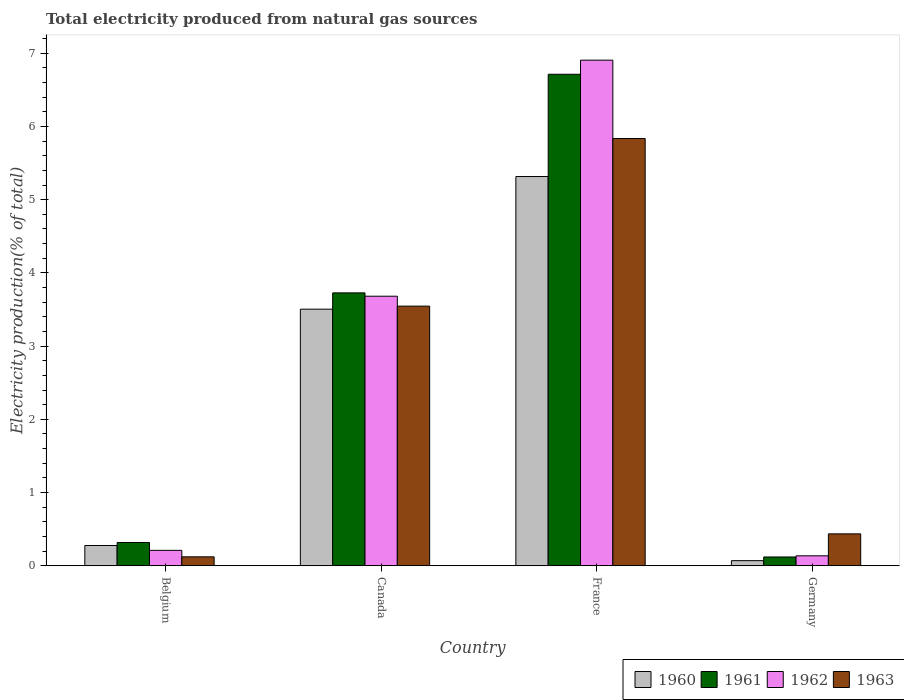How many bars are there on the 1st tick from the left?
Your response must be concise. 4. What is the label of the 3rd group of bars from the left?
Your answer should be very brief. France. What is the total electricity produced in 1961 in Canada?
Ensure brevity in your answer.  3.73. Across all countries, what is the maximum total electricity produced in 1963?
Your answer should be compact. 5.83. Across all countries, what is the minimum total electricity produced in 1962?
Offer a terse response. 0.14. What is the total total electricity produced in 1962 in the graph?
Ensure brevity in your answer.  10.93. What is the difference between the total electricity produced in 1960 in Canada and that in Germany?
Your answer should be compact. 3.43. What is the difference between the total electricity produced in 1963 in France and the total electricity produced in 1960 in Canada?
Provide a short and direct response. 2.33. What is the average total electricity produced in 1960 per country?
Offer a terse response. 2.29. What is the difference between the total electricity produced of/in 1960 and total electricity produced of/in 1963 in Belgium?
Your response must be concise. 0.15. In how many countries, is the total electricity produced in 1962 greater than 3.2 %?
Your answer should be compact. 2. What is the ratio of the total electricity produced in 1963 in Belgium to that in France?
Give a very brief answer. 0.02. Is the difference between the total electricity produced in 1960 in Canada and France greater than the difference between the total electricity produced in 1963 in Canada and France?
Keep it short and to the point. Yes. What is the difference between the highest and the second highest total electricity produced in 1962?
Provide a short and direct response. -3.47. What is the difference between the highest and the lowest total electricity produced in 1961?
Provide a short and direct response. 6.59. Is it the case that in every country, the sum of the total electricity produced in 1960 and total electricity produced in 1962 is greater than the sum of total electricity produced in 1963 and total electricity produced in 1961?
Ensure brevity in your answer.  No. What does the 4th bar from the right in Belgium represents?
Your answer should be compact. 1960. How many bars are there?
Your answer should be compact. 16. Are all the bars in the graph horizontal?
Your answer should be very brief. No. How many countries are there in the graph?
Provide a succinct answer. 4. What is the difference between two consecutive major ticks on the Y-axis?
Ensure brevity in your answer.  1. Does the graph contain any zero values?
Your answer should be very brief. No. Where does the legend appear in the graph?
Your answer should be compact. Bottom right. How many legend labels are there?
Provide a short and direct response. 4. What is the title of the graph?
Keep it short and to the point. Total electricity produced from natural gas sources. What is the label or title of the Y-axis?
Keep it short and to the point. Electricity production(% of total). What is the Electricity production(% of total) of 1960 in Belgium?
Make the answer very short. 0.28. What is the Electricity production(% of total) in 1961 in Belgium?
Your answer should be compact. 0.32. What is the Electricity production(% of total) in 1962 in Belgium?
Your answer should be very brief. 0.21. What is the Electricity production(% of total) in 1963 in Belgium?
Provide a succinct answer. 0.12. What is the Electricity production(% of total) of 1960 in Canada?
Provide a short and direct response. 3.5. What is the Electricity production(% of total) in 1961 in Canada?
Your answer should be compact. 3.73. What is the Electricity production(% of total) of 1962 in Canada?
Ensure brevity in your answer.  3.68. What is the Electricity production(% of total) of 1963 in Canada?
Give a very brief answer. 3.55. What is the Electricity production(% of total) of 1960 in France?
Offer a terse response. 5.32. What is the Electricity production(% of total) of 1961 in France?
Give a very brief answer. 6.71. What is the Electricity production(% of total) in 1962 in France?
Your response must be concise. 6.91. What is the Electricity production(% of total) in 1963 in France?
Keep it short and to the point. 5.83. What is the Electricity production(% of total) of 1960 in Germany?
Keep it short and to the point. 0.07. What is the Electricity production(% of total) in 1961 in Germany?
Your response must be concise. 0.12. What is the Electricity production(% of total) of 1962 in Germany?
Provide a short and direct response. 0.14. What is the Electricity production(% of total) in 1963 in Germany?
Your answer should be compact. 0.44. Across all countries, what is the maximum Electricity production(% of total) in 1960?
Your answer should be very brief. 5.32. Across all countries, what is the maximum Electricity production(% of total) of 1961?
Your answer should be compact. 6.71. Across all countries, what is the maximum Electricity production(% of total) of 1962?
Give a very brief answer. 6.91. Across all countries, what is the maximum Electricity production(% of total) in 1963?
Your answer should be compact. 5.83. Across all countries, what is the minimum Electricity production(% of total) in 1960?
Keep it short and to the point. 0.07. Across all countries, what is the minimum Electricity production(% of total) in 1961?
Your response must be concise. 0.12. Across all countries, what is the minimum Electricity production(% of total) of 1962?
Give a very brief answer. 0.14. Across all countries, what is the minimum Electricity production(% of total) in 1963?
Your response must be concise. 0.12. What is the total Electricity production(% of total) in 1960 in the graph?
Your response must be concise. 9.17. What is the total Electricity production(% of total) of 1961 in the graph?
Provide a short and direct response. 10.88. What is the total Electricity production(% of total) in 1962 in the graph?
Keep it short and to the point. 10.93. What is the total Electricity production(% of total) in 1963 in the graph?
Provide a short and direct response. 9.94. What is the difference between the Electricity production(% of total) in 1960 in Belgium and that in Canada?
Your answer should be compact. -3.23. What is the difference between the Electricity production(% of total) in 1961 in Belgium and that in Canada?
Your response must be concise. -3.41. What is the difference between the Electricity production(% of total) in 1962 in Belgium and that in Canada?
Make the answer very short. -3.47. What is the difference between the Electricity production(% of total) of 1963 in Belgium and that in Canada?
Your answer should be very brief. -3.42. What is the difference between the Electricity production(% of total) of 1960 in Belgium and that in France?
Provide a short and direct response. -5.04. What is the difference between the Electricity production(% of total) in 1961 in Belgium and that in France?
Make the answer very short. -6.39. What is the difference between the Electricity production(% of total) of 1962 in Belgium and that in France?
Offer a very short reply. -6.69. What is the difference between the Electricity production(% of total) of 1963 in Belgium and that in France?
Your response must be concise. -5.71. What is the difference between the Electricity production(% of total) in 1960 in Belgium and that in Germany?
Ensure brevity in your answer.  0.21. What is the difference between the Electricity production(% of total) of 1961 in Belgium and that in Germany?
Offer a terse response. 0.2. What is the difference between the Electricity production(% of total) in 1962 in Belgium and that in Germany?
Keep it short and to the point. 0.07. What is the difference between the Electricity production(% of total) of 1963 in Belgium and that in Germany?
Ensure brevity in your answer.  -0.31. What is the difference between the Electricity production(% of total) of 1960 in Canada and that in France?
Keep it short and to the point. -1.81. What is the difference between the Electricity production(% of total) in 1961 in Canada and that in France?
Offer a very short reply. -2.99. What is the difference between the Electricity production(% of total) of 1962 in Canada and that in France?
Give a very brief answer. -3.22. What is the difference between the Electricity production(% of total) in 1963 in Canada and that in France?
Keep it short and to the point. -2.29. What is the difference between the Electricity production(% of total) in 1960 in Canada and that in Germany?
Ensure brevity in your answer.  3.43. What is the difference between the Electricity production(% of total) of 1961 in Canada and that in Germany?
Give a very brief answer. 3.61. What is the difference between the Electricity production(% of total) of 1962 in Canada and that in Germany?
Offer a terse response. 3.55. What is the difference between the Electricity production(% of total) of 1963 in Canada and that in Germany?
Give a very brief answer. 3.11. What is the difference between the Electricity production(% of total) in 1960 in France and that in Germany?
Provide a succinct answer. 5.25. What is the difference between the Electricity production(% of total) of 1961 in France and that in Germany?
Offer a very short reply. 6.59. What is the difference between the Electricity production(% of total) in 1962 in France and that in Germany?
Offer a terse response. 6.77. What is the difference between the Electricity production(% of total) of 1963 in France and that in Germany?
Your answer should be very brief. 5.4. What is the difference between the Electricity production(% of total) in 1960 in Belgium and the Electricity production(% of total) in 1961 in Canada?
Your answer should be very brief. -3.45. What is the difference between the Electricity production(% of total) in 1960 in Belgium and the Electricity production(% of total) in 1962 in Canada?
Your answer should be compact. -3.4. What is the difference between the Electricity production(% of total) of 1960 in Belgium and the Electricity production(% of total) of 1963 in Canada?
Your response must be concise. -3.27. What is the difference between the Electricity production(% of total) in 1961 in Belgium and the Electricity production(% of total) in 1962 in Canada?
Your answer should be compact. -3.36. What is the difference between the Electricity production(% of total) in 1961 in Belgium and the Electricity production(% of total) in 1963 in Canada?
Ensure brevity in your answer.  -3.23. What is the difference between the Electricity production(% of total) in 1962 in Belgium and the Electricity production(% of total) in 1963 in Canada?
Your answer should be compact. -3.34. What is the difference between the Electricity production(% of total) of 1960 in Belgium and the Electricity production(% of total) of 1961 in France?
Give a very brief answer. -6.43. What is the difference between the Electricity production(% of total) in 1960 in Belgium and the Electricity production(% of total) in 1962 in France?
Offer a very short reply. -6.63. What is the difference between the Electricity production(% of total) in 1960 in Belgium and the Electricity production(% of total) in 1963 in France?
Provide a succinct answer. -5.56. What is the difference between the Electricity production(% of total) in 1961 in Belgium and the Electricity production(% of total) in 1962 in France?
Provide a short and direct response. -6.59. What is the difference between the Electricity production(% of total) of 1961 in Belgium and the Electricity production(% of total) of 1963 in France?
Offer a terse response. -5.52. What is the difference between the Electricity production(% of total) in 1962 in Belgium and the Electricity production(% of total) in 1963 in France?
Keep it short and to the point. -5.62. What is the difference between the Electricity production(% of total) in 1960 in Belgium and the Electricity production(% of total) in 1961 in Germany?
Keep it short and to the point. 0.16. What is the difference between the Electricity production(% of total) in 1960 in Belgium and the Electricity production(% of total) in 1962 in Germany?
Provide a short and direct response. 0.14. What is the difference between the Electricity production(% of total) of 1960 in Belgium and the Electricity production(% of total) of 1963 in Germany?
Provide a succinct answer. -0.16. What is the difference between the Electricity production(% of total) of 1961 in Belgium and the Electricity production(% of total) of 1962 in Germany?
Ensure brevity in your answer.  0.18. What is the difference between the Electricity production(% of total) of 1961 in Belgium and the Electricity production(% of total) of 1963 in Germany?
Give a very brief answer. -0.12. What is the difference between the Electricity production(% of total) of 1962 in Belgium and the Electricity production(% of total) of 1963 in Germany?
Offer a very short reply. -0.23. What is the difference between the Electricity production(% of total) in 1960 in Canada and the Electricity production(% of total) in 1961 in France?
Give a very brief answer. -3.21. What is the difference between the Electricity production(% of total) of 1960 in Canada and the Electricity production(% of total) of 1962 in France?
Give a very brief answer. -3.4. What is the difference between the Electricity production(% of total) of 1960 in Canada and the Electricity production(% of total) of 1963 in France?
Your answer should be very brief. -2.33. What is the difference between the Electricity production(% of total) of 1961 in Canada and the Electricity production(% of total) of 1962 in France?
Your answer should be compact. -3.18. What is the difference between the Electricity production(% of total) of 1961 in Canada and the Electricity production(% of total) of 1963 in France?
Your response must be concise. -2.11. What is the difference between the Electricity production(% of total) of 1962 in Canada and the Electricity production(% of total) of 1963 in France?
Give a very brief answer. -2.15. What is the difference between the Electricity production(% of total) in 1960 in Canada and the Electricity production(% of total) in 1961 in Germany?
Give a very brief answer. 3.38. What is the difference between the Electricity production(% of total) in 1960 in Canada and the Electricity production(% of total) in 1962 in Germany?
Give a very brief answer. 3.37. What is the difference between the Electricity production(% of total) of 1960 in Canada and the Electricity production(% of total) of 1963 in Germany?
Provide a short and direct response. 3.07. What is the difference between the Electricity production(% of total) of 1961 in Canada and the Electricity production(% of total) of 1962 in Germany?
Offer a terse response. 3.59. What is the difference between the Electricity production(% of total) of 1961 in Canada and the Electricity production(% of total) of 1963 in Germany?
Give a very brief answer. 3.29. What is the difference between the Electricity production(% of total) in 1962 in Canada and the Electricity production(% of total) in 1963 in Germany?
Your response must be concise. 3.25. What is the difference between the Electricity production(% of total) in 1960 in France and the Electricity production(% of total) in 1961 in Germany?
Make the answer very short. 5.2. What is the difference between the Electricity production(% of total) of 1960 in France and the Electricity production(% of total) of 1962 in Germany?
Your answer should be very brief. 5.18. What is the difference between the Electricity production(% of total) in 1960 in France and the Electricity production(% of total) in 1963 in Germany?
Your answer should be compact. 4.88. What is the difference between the Electricity production(% of total) in 1961 in France and the Electricity production(% of total) in 1962 in Germany?
Your answer should be very brief. 6.58. What is the difference between the Electricity production(% of total) of 1961 in France and the Electricity production(% of total) of 1963 in Germany?
Your answer should be compact. 6.28. What is the difference between the Electricity production(% of total) in 1962 in France and the Electricity production(% of total) in 1963 in Germany?
Make the answer very short. 6.47. What is the average Electricity production(% of total) in 1960 per country?
Make the answer very short. 2.29. What is the average Electricity production(% of total) in 1961 per country?
Make the answer very short. 2.72. What is the average Electricity production(% of total) of 1962 per country?
Offer a terse response. 2.73. What is the average Electricity production(% of total) in 1963 per country?
Your answer should be very brief. 2.48. What is the difference between the Electricity production(% of total) of 1960 and Electricity production(% of total) of 1961 in Belgium?
Your answer should be compact. -0.04. What is the difference between the Electricity production(% of total) in 1960 and Electricity production(% of total) in 1962 in Belgium?
Keep it short and to the point. 0.07. What is the difference between the Electricity production(% of total) in 1960 and Electricity production(% of total) in 1963 in Belgium?
Give a very brief answer. 0.15. What is the difference between the Electricity production(% of total) of 1961 and Electricity production(% of total) of 1962 in Belgium?
Offer a terse response. 0.11. What is the difference between the Electricity production(% of total) in 1961 and Electricity production(% of total) in 1963 in Belgium?
Your answer should be very brief. 0.2. What is the difference between the Electricity production(% of total) of 1962 and Electricity production(% of total) of 1963 in Belgium?
Make the answer very short. 0.09. What is the difference between the Electricity production(% of total) in 1960 and Electricity production(% of total) in 1961 in Canada?
Provide a succinct answer. -0.22. What is the difference between the Electricity production(% of total) of 1960 and Electricity production(% of total) of 1962 in Canada?
Your answer should be compact. -0.18. What is the difference between the Electricity production(% of total) of 1960 and Electricity production(% of total) of 1963 in Canada?
Make the answer very short. -0.04. What is the difference between the Electricity production(% of total) in 1961 and Electricity production(% of total) in 1962 in Canada?
Your response must be concise. 0.05. What is the difference between the Electricity production(% of total) of 1961 and Electricity production(% of total) of 1963 in Canada?
Your answer should be very brief. 0.18. What is the difference between the Electricity production(% of total) in 1962 and Electricity production(% of total) in 1963 in Canada?
Make the answer very short. 0.14. What is the difference between the Electricity production(% of total) of 1960 and Electricity production(% of total) of 1961 in France?
Ensure brevity in your answer.  -1.4. What is the difference between the Electricity production(% of total) of 1960 and Electricity production(% of total) of 1962 in France?
Offer a terse response. -1.59. What is the difference between the Electricity production(% of total) in 1960 and Electricity production(% of total) in 1963 in France?
Offer a very short reply. -0.52. What is the difference between the Electricity production(% of total) of 1961 and Electricity production(% of total) of 1962 in France?
Give a very brief answer. -0.19. What is the difference between the Electricity production(% of total) in 1961 and Electricity production(% of total) in 1963 in France?
Your response must be concise. 0.88. What is the difference between the Electricity production(% of total) in 1962 and Electricity production(% of total) in 1963 in France?
Provide a succinct answer. 1.07. What is the difference between the Electricity production(% of total) of 1960 and Electricity production(% of total) of 1962 in Germany?
Offer a very short reply. -0.07. What is the difference between the Electricity production(% of total) of 1960 and Electricity production(% of total) of 1963 in Germany?
Offer a terse response. -0.37. What is the difference between the Electricity production(% of total) in 1961 and Electricity production(% of total) in 1962 in Germany?
Your answer should be compact. -0.02. What is the difference between the Electricity production(% of total) in 1961 and Electricity production(% of total) in 1963 in Germany?
Make the answer very short. -0.32. What is the difference between the Electricity production(% of total) of 1962 and Electricity production(% of total) of 1963 in Germany?
Your answer should be very brief. -0.3. What is the ratio of the Electricity production(% of total) of 1960 in Belgium to that in Canada?
Ensure brevity in your answer.  0.08. What is the ratio of the Electricity production(% of total) in 1961 in Belgium to that in Canada?
Give a very brief answer. 0.09. What is the ratio of the Electricity production(% of total) of 1962 in Belgium to that in Canada?
Offer a very short reply. 0.06. What is the ratio of the Electricity production(% of total) in 1963 in Belgium to that in Canada?
Keep it short and to the point. 0.03. What is the ratio of the Electricity production(% of total) in 1960 in Belgium to that in France?
Provide a short and direct response. 0.05. What is the ratio of the Electricity production(% of total) of 1961 in Belgium to that in France?
Your answer should be very brief. 0.05. What is the ratio of the Electricity production(% of total) of 1962 in Belgium to that in France?
Your answer should be very brief. 0.03. What is the ratio of the Electricity production(% of total) in 1963 in Belgium to that in France?
Provide a succinct answer. 0.02. What is the ratio of the Electricity production(% of total) of 1960 in Belgium to that in Germany?
Ensure brevity in your answer.  3.94. What is the ratio of the Electricity production(% of total) of 1961 in Belgium to that in Germany?
Make the answer very short. 2.64. What is the ratio of the Electricity production(% of total) in 1962 in Belgium to that in Germany?
Provide a short and direct response. 1.55. What is the ratio of the Electricity production(% of total) in 1963 in Belgium to that in Germany?
Provide a short and direct response. 0.28. What is the ratio of the Electricity production(% of total) of 1960 in Canada to that in France?
Ensure brevity in your answer.  0.66. What is the ratio of the Electricity production(% of total) of 1961 in Canada to that in France?
Your answer should be very brief. 0.56. What is the ratio of the Electricity production(% of total) of 1962 in Canada to that in France?
Your response must be concise. 0.53. What is the ratio of the Electricity production(% of total) of 1963 in Canada to that in France?
Provide a short and direct response. 0.61. What is the ratio of the Electricity production(% of total) of 1960 in Canada to that in Germany?
Offer a very short reply. 49.85. What is the ratio of the Electricity production(% of total) in 1961 in Canada to that in Germany?
Make the answer very short. 30.98. What is the ratio of the Electricity production(% of total) of 1962 in Canada to that in Germany?
Provide a short and direct response. 27.02. What is the ratio of the Electricity production(% of total) in 1963 in Canada to that in Germany?
Your answer should be compact. 8.13. What is the ratio of the Electricity production(% of total) in 1960 in France to that in Germany?
Give a very brief answer. 75.62. What is the ratio of the Electricity production(% of total) in 1961 in France to that in Germany?
Your answer should be very brief. 55.79. What is the ratio of the Electricity production(% of total) of 1962 in France to that in Germany?
Your answer should be compact. 50.69. What is the ratio of the Electricity production(% of total) in 1963 in France to that in Germany?
Offer a terse response. 13.38. What is the difference between the highest and the second highest Electricity production(% of total) of 1960?
Provide a succinct answer. 1.81. What is the difference between the highest and the second highest Electricity production(% of total) in 1961?
Your response must be concise. 2.99. What is the difference between the highest and the second highest Electricity production(% of total) of 1962?
Keep it short and to the point. 3.22. What is the difference between the highest and the second highest Electricity production(% of total) of 1963?
Provide a succinct answer. 2.29. What is the difference between the highest and the lowest Electricity production(% of total) of 1960?
Keep it short and to the point. 5.25. What is the difference between the highest and the lowest Electricity production(% of total) in 1961?
Your answer should be compact. 6.59. What is the difference between the highest and the lowest Electricity production(% of total) in 1962?
Offer a terse response. 6.77. What is the difference between the highest and the lowest Electricity production(% of total) of 1963?
Your answer should be compact. 5.71. 